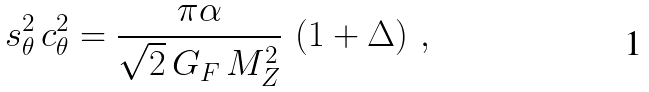<formula> <loc_0><loc_0><loc_500><loc_500>s ^ { 2 } _ { \theta } \, c ^ { 2 } _ { \theta } = \frac { \pi \alpha } { \sqrt { 2 } \, G _ { F } \, M _ { Z } ^ { 2 } } \, \left ( 1 + \Delta \right ) \, ,</formula> 